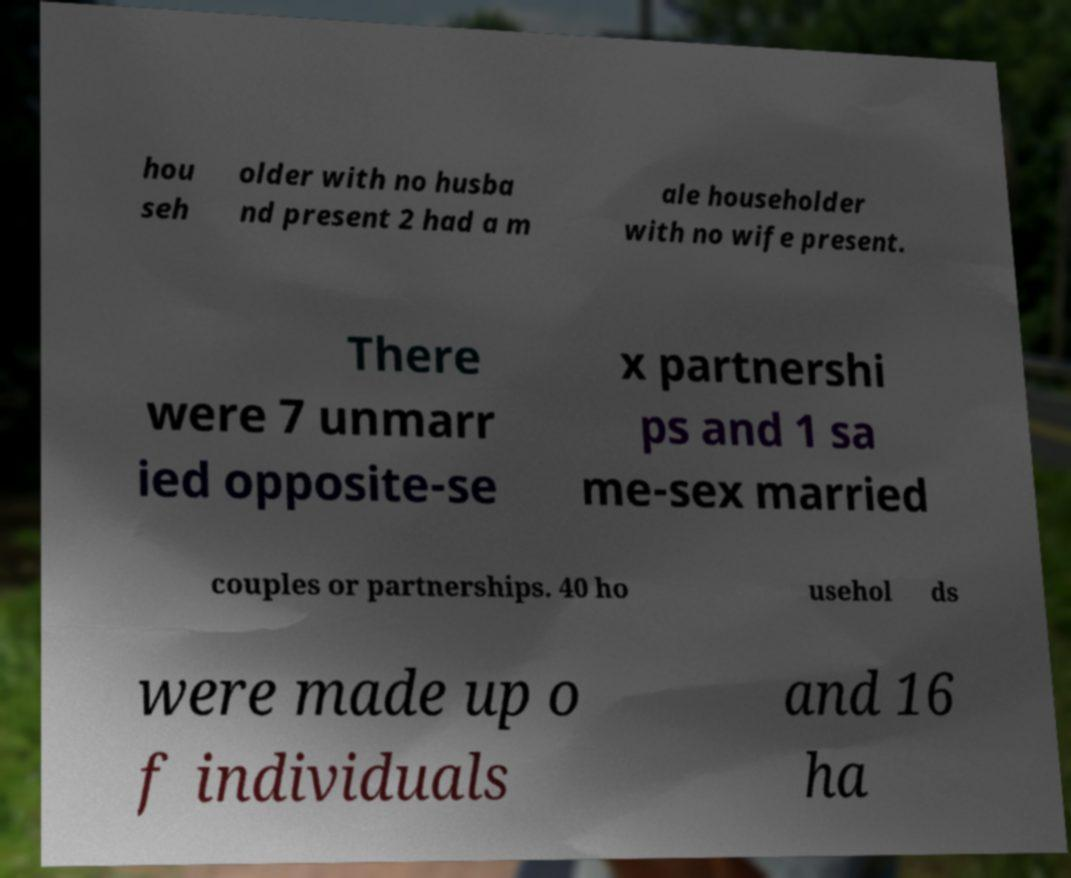Could you assist in decoding the text presented in this image and type it out clearly? hou seh older with no husba nd present 2 had a m ale householder with no wife present. There were 7 unmarr ied opposite-se x partnershi ps and 1 sa me-sex married couples or partnerships. 40 ho usehol ds were made up o f individuals and 16 ha 